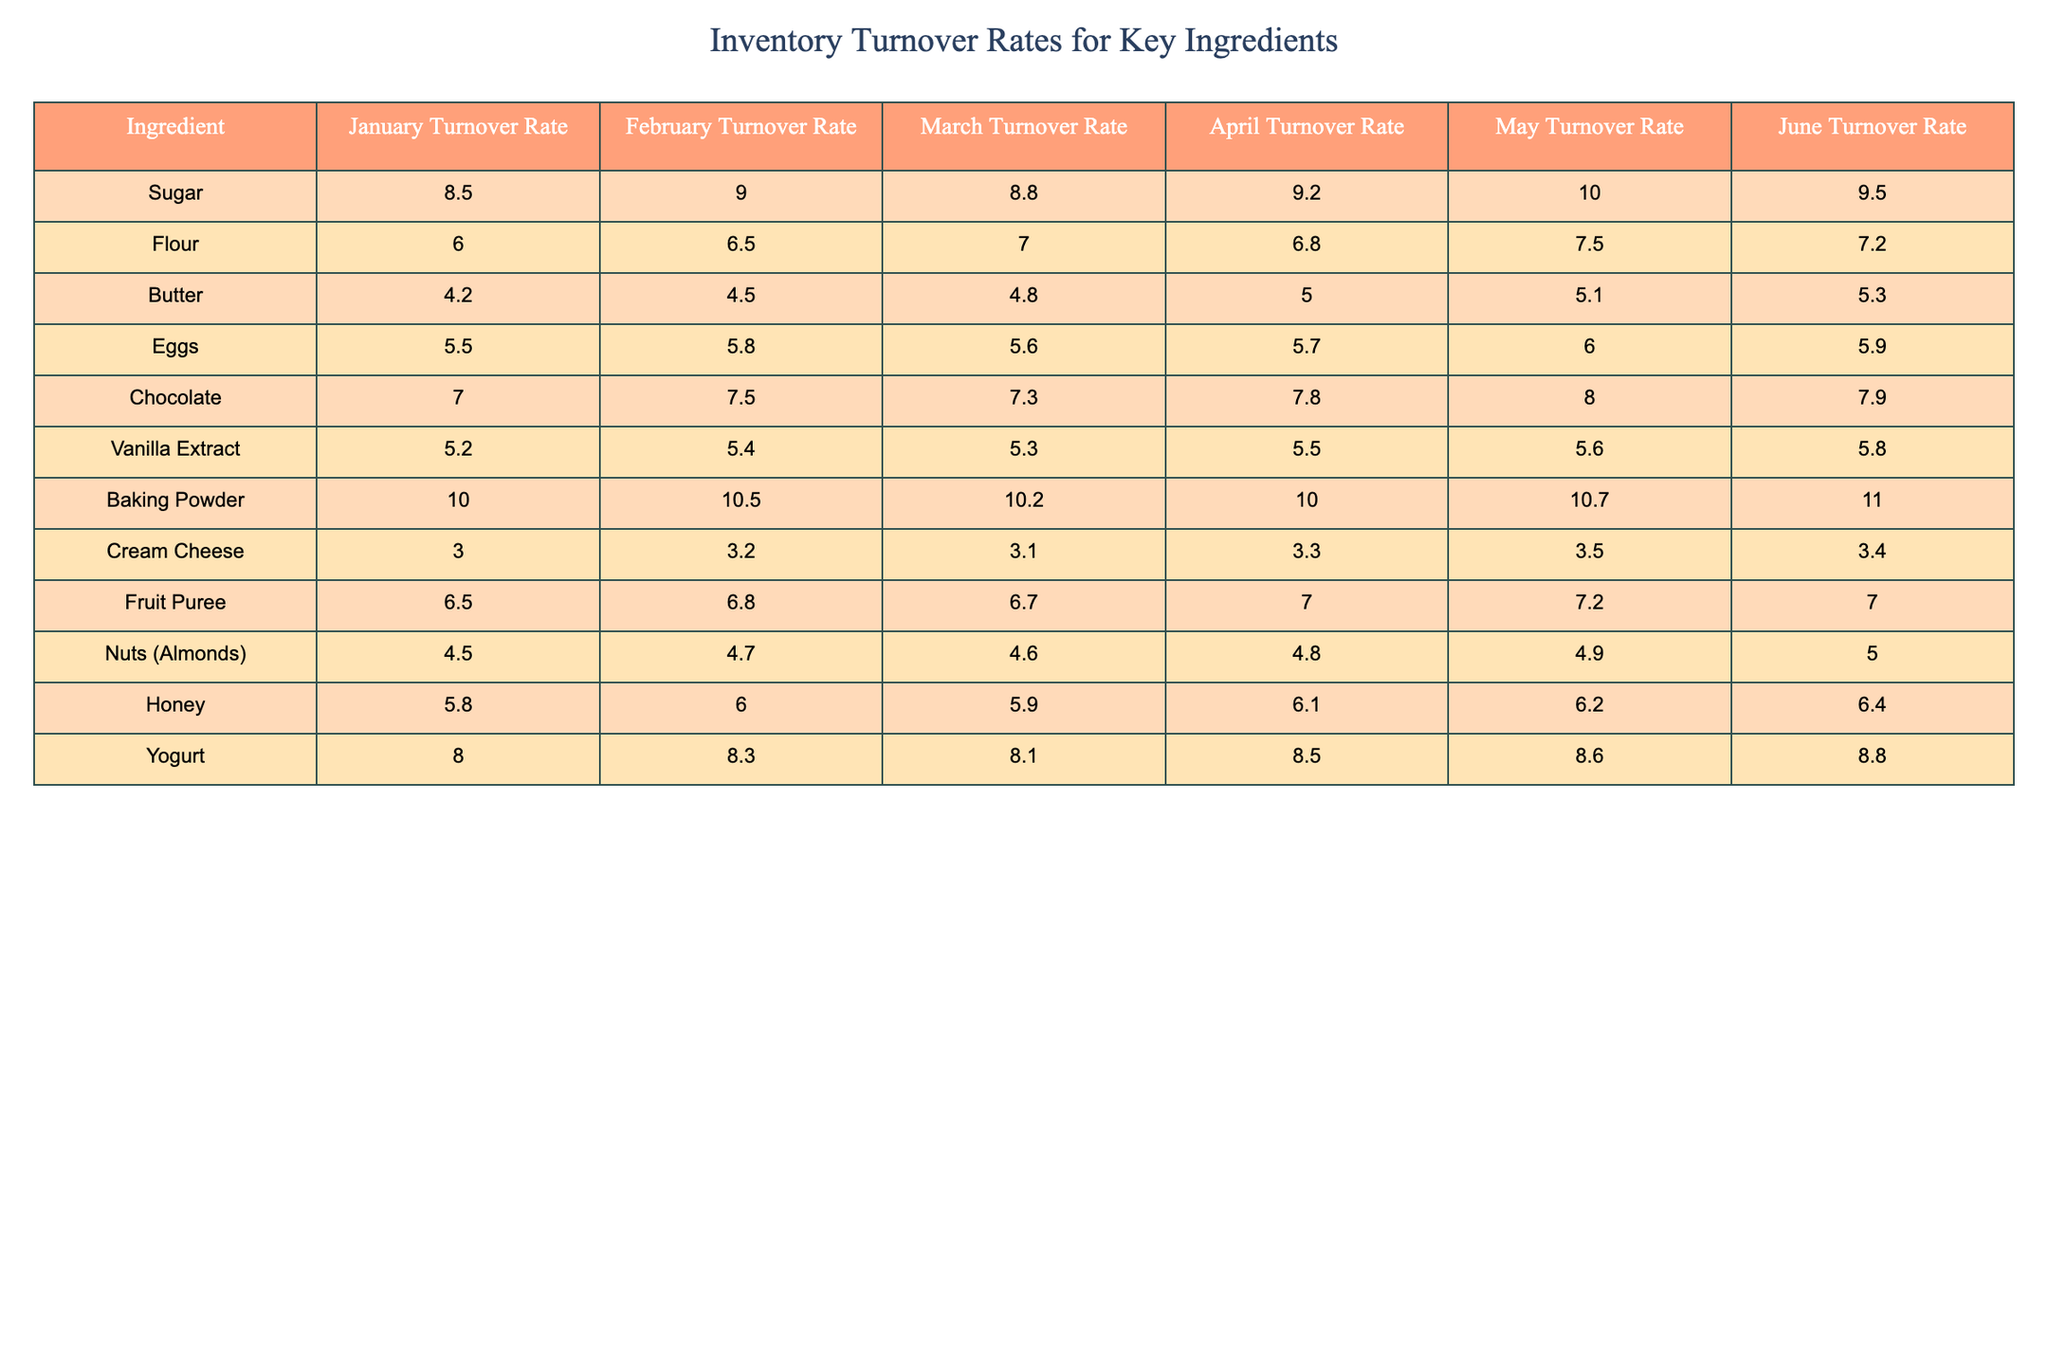What is the turnover rate of Sugar in May? From the table, we can directly look at the Sugar row and find the turnover rate for May, which is listed as 10.0.
Answer: 10.0 Which ingredient had the highest turnover rate in June? By examining the June column in the table, we can see that Baking Powder has the highest turnover rate of 11.0.
Answer: Baking Powder Calculate the average turnover rate for Butter over the six months. To find the average, we sum the turnover rates for Butter from January to June: (4.2 + 4.5 + 4.8 + 5.0 + 5.1 + 5.3) = 29.9, then divide by 6, giving 29.9 / 6 = 4.9833, which rounds to 5.0.
Answer: 5.0 Did the turnover rate for Flour increase in April compared to March? Looking at the table, Flour's turnover rate in March is 7.0 and in April it decreased to 6.8. Therefore, the turnover rate did not increase.
Answer: No What is the difference between the highest and lowest turnover rates for Eggs and Cream Cheese combined for the month of February? In February, Eggs have a turnover rate of 5.8 and Cream Cheese has 3.2. The highest is 5.8 and the lowest is 3.2. The difference is 5.8 - 3.2 = 2.6.
Answer: 2.6 Which two ingredients had the most similar turnover rates in March? In March, the turnover rates are: Eggs 5.6, Butter 4.8, Sugar 8.8, etc. Butter (4.8) and Eggs (5.6) have a difference of 0.8, which is the smallest.
Answer: Butter and Eggs For which ingredient did the turnover rate increase every month from January to June? Observing the table, we find that Baking Powder's turnover rates are consistently increasing: 10.0, 10.5, 10.2, 10.0, 10.7, 11.0. Therefore, it did not increase every month. Chocolate also shows a steady increase until June.
Answer: None What is the total turnover rate for Fruit Puree from January to June? Adding the turnover rates for Fruit Puree over the six months gives: 6.5 + 6.8 + 6.7 + 7.0 + 7.2 + 7.0 = 41.2.
Answer: 41.2 Which ingredient has a turnover rate of exactly 5.5 in any month? By inspecting the table, we find that Vanilla Extract has a turnover rate of 5.5 in April, and Eggs have 5.5 in January. In April, Vanilla Extract fits this criterion.
Answer: Vanilla Extract Compare the turnover rates of Yogurt and Honey in May. Which one is higher? In May, Yogurt has a turnover rate of 8.6 while Honey's rate is 6.2. Thus, Yogurt is higher.
Answer: Yogurt 